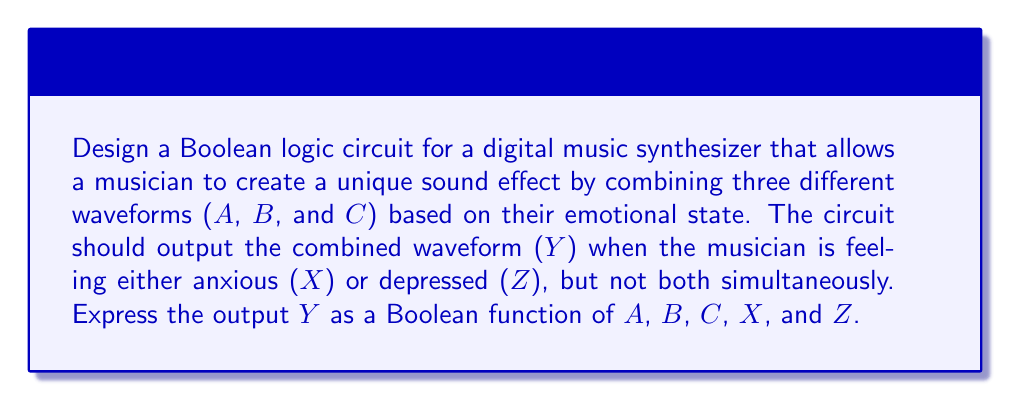Could you help me with this problem? Let's approach this step-by-step:

1) First, we need to understand the conditions for the output Y:
   - Y should be active when X (anxious) OR Z (depressed) is true, but not both.
   - When Y is active, it should combine waveforms A, B, and C.

2) The condition "X or Z, but not both" can be represented by the XOR operation: $X \oplus Z$

3) When this condition is met, we want to combine A, B, and C. In Boolean algebra, combining typically means using the OR operation.

4) So, our function will look like this:
   $Y = (X \oplus Z) \cdot (A + B + C)$

5) Let's expand this using the definition of XOR:
   $X \oplus Z = X\bar{Z} + \bar{X}Z$

6) Substituting this back into our original function:
   $Y = (X\bar{Z} + \bar{X}Z) \cdot (A + B + C)$

7) Using the distributive property:
   $Y = X\bar{Z}(A + B + C) + \bar{X}Z(A + B + C)$

This is our final Boolean function for the circuit.
Answer: $Y = X\bar{Z}(A + B + C) + \bar{X}Z(A + B + C)$ 